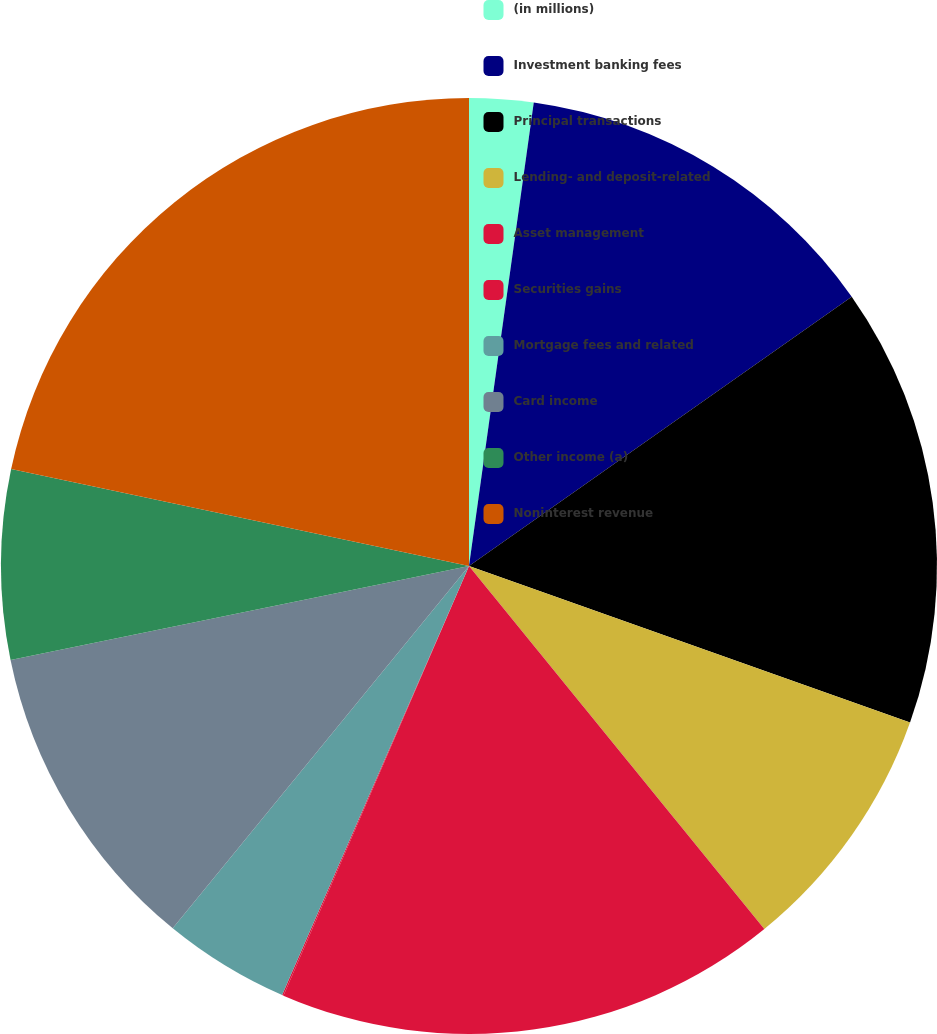<chart> <loc_0><loc_0><loc_500><loc_500><pie_chart><fcel>(in millions)<fcel>Investment banking fees<fcel>Principal transactions<fcel>Lending- and deposit-related<fcel>Asset management<fcel>Securities gains<fcel>Mortgage fees and related<fcel>Card income<fcel>Other income (a)<fcel>Noninterest revenue<nl><fcel>2.21%<fcel>13.03%<fcel>15.19%<fcel>8.7%<fcel>17.36%<fcel>0.05%<fcel>4.37%<fcel>10.87%<fcel>6.54%<fcel>21.68%<nl></chart> 